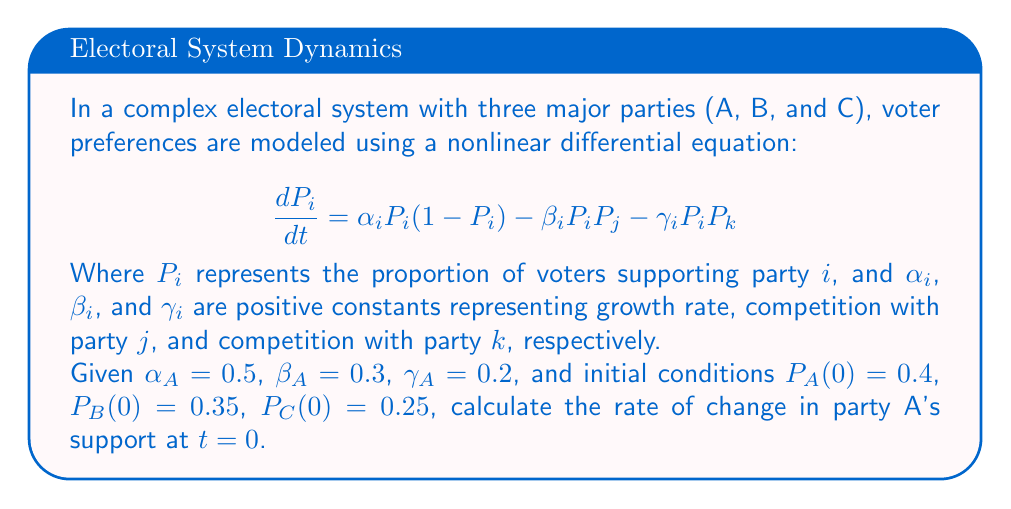Show me your answer to this math problem. To solve this problem, we'll follow these steps:

1) The given equation for party A's support is:
   $$\frac{dP_A}{dt} = \alpha_A P_A(1-P_A) - \beta_A P_A P_B - \gamma_A P_A P_C$$

2) We're given the following values:
   $\alpha_A = 0.5$
   $\beta_A = 0.3$
   $\gamma_A = 0.2$
   $P_A(0) = 0.4$
   $P_B(0) = 0.35$
   $P_C(0) = 0.25$

3) Let's substitute these values into the equation:
   $$\frac{dP_A}{dt} = 0.5 \cdot 0.4(1-0.4) - 0.3 \cdot 0.4 \cdot 0.35 - 0.2 \cdot 0.4 \cdot 0.25$$

4) Now, let's calculate each term:
   - First term: $0.5 \cdot 0.4 \cdot 0.6 = 0.12$
   - Second term: $0.3 \cdot 0.4 \cdot 0.35 = 0.042$
   - Third term: $0.2 \cdot 0.4 \cdot 0.25 = 0.02$

5) Finally, we can calculate the rate of change:
   $$\frac{dP_A}{dt} = 0.12 - 0.042 - 0.02 = 0.058$$

Therefore, at $t=0$, the rate of change in party A's support is 0.058 or 5.8% per unit time.
Answer: 0.058 